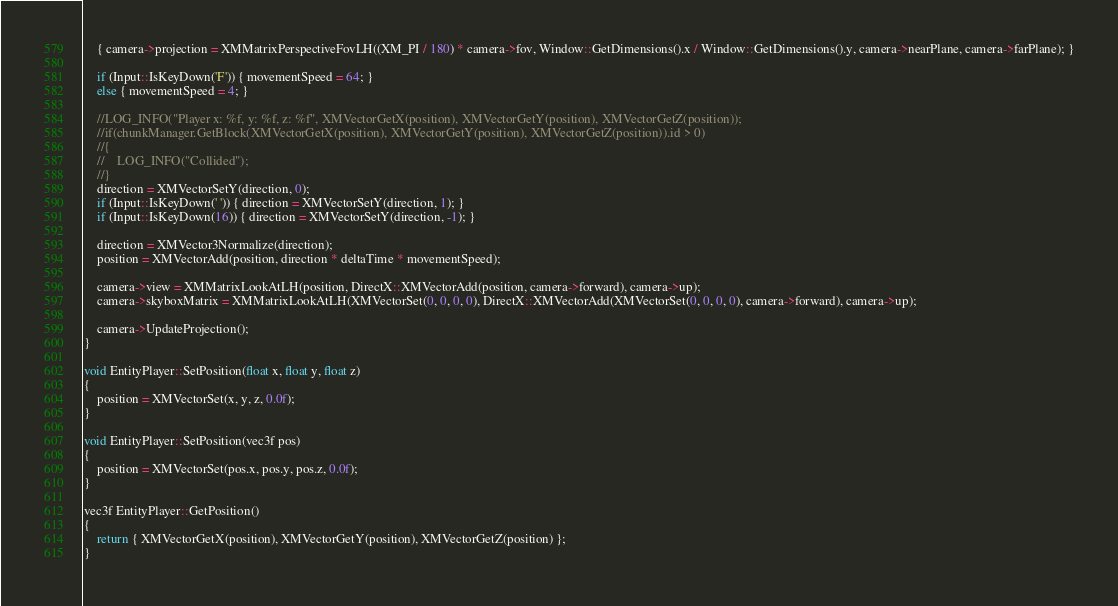Convert code to text. <code><loc_0><loc_0><loc_500><loc_500><_C++_>    { camera->projection = XMMatrixPerspectiveFovLH((XM_PI / 180) * camera->fov, Window::GetDimensions().x / Window::GetDimensions().y, camera->nearPlane, camera->farPlane); }

    if (Input::IsKeyDown('F')) { movementSpeed = 64; }
    else { movementSpeed = 4; }

    //LOG_INFO("Player x: %f, y: %f, z: %f", XMVectorGetX(position), XMVectorGetY(position), XMVectorGetZ(position));
    //if(chunkManager.GetBlock(XMVectorGetX(position), XMVectorGetY(position), XMVectorGetZ(position)).id > 0)
    //{
    //    LOG_INFO("Collided");
    //}
    direction = XMVectorSetY(direction, 0);
    if (Input::IsKeyDown(' ')) { direction = XMVectorSetY(direction, 1); }
    if (Input::IsKeyDown(16)) { direction = XMVectorSetY(direction, -1); }

    direction = XMVector3Normalize(direction);
    position = XMVectorAdd(position, direction * deltaTime * movementSpeed);

    camera->view = XMMatrixLookAtLH(position, DirectX::XMVectorAdd(position, camera->forward), camera->up);
    camera->skyboxMatrix = XMMatrixLookAtLH(XMVectorSet(0, 0, 0, 0), DirectX::XMVectorAdd(XMVectorSet(0, 0, 0, 0), camera->forward), camera->up);

    camera->UpdateProjection();
}

void EntityPlayer::SetPosition(float x, float y, float z)
{
    position = XMVectorSet(x, y, z, 0.0f);
}

void EntityPlayer::SetPosition(vec3f pos)
{
    position = XMVectorSet(pos.x, pos.y, pos.z, 0.0f);
}

vec3f EntityPlayer::GetPosition()
{
    return { XMVectorGetX(position), XMVectorGetY(position), XMVectorGetZ(position) };
}
</code> 